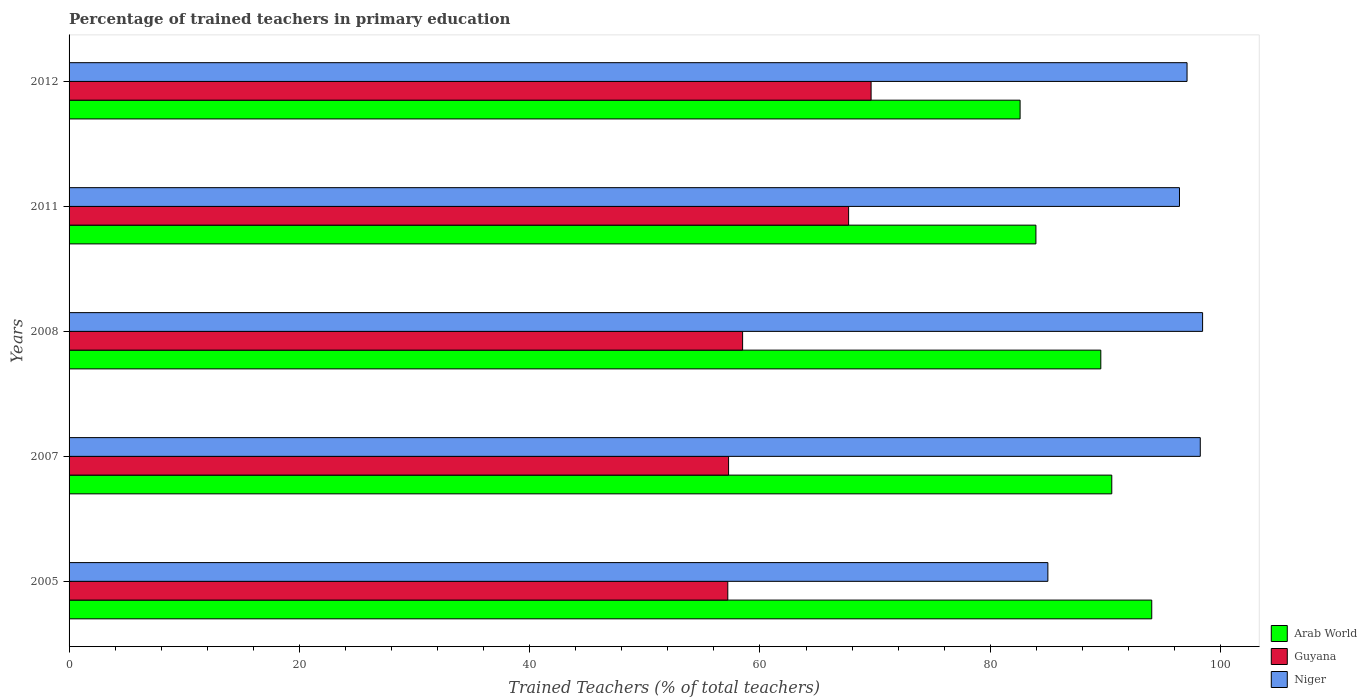How many groups of bars are there?
Keep it short and to the point. 5. How many bars are there on the 5th tick from the top?
Provide a succinct answer. 3. How many bars are there on the 4th tick from the bottom?
Offer a terse response. 3. What is the label of the 2nd group of bars from the top?
Provide a short and direct response. 2011. What is the percentage of trained teachers in Guyana in 2012?
Your answer should be compact. 69.65. Across all years, what is the maximum percentage of trained teachers in Arab World?
Provide a succinct answer. 94.02. Across all years, what is the minimum percentage of trained teachers in Guyana?
Ensure brevity in your answer.  57.2. In which year was the percentage of trained teachers in Guyana maximum?
Keep it short and to the point. 2012. What is the total percentage of trained teachers in Guyana in the graph?
Offer a terse response. 310.32. What is the difference between the percentage of trained teachers in Guyana in 2005 and that in 2011?
Offer a terse response. -10.49. What is the difference between the percentage of trained teachers in Arab World in 2005 and the percentage of trained teachers in Guyana in 2012?
Ensure brevity in your answer.  24.37. What is the average percentage of trained teachers in Arab World per year?
Ensure brevity in your answer.  88.14. In the year 2012, what is the difference between the percentage of trained teachers in Guyana and percentage of trained teachers in Arab World?
Provide a short and direct response. -12.94. What is the ratio of the percentage of trained teachers in Niger in 2007 to that in 2011?
Make the answer very short. 1.02. Is the difference between the percentage of trained teachers in Guyana in 2011 and 2012 greater than the difference between the percentage of trained teachers in Arab World in 2011 and 2012?
Ensure brevity in your answer.  No. What is the difference between the highest and the second highest percentage of trained teachers in Guyana?
Your response must be concise. 1.95. What is the difference between the highest and the lowest percentage of trained teachers in Niger?
Your response must be concise. 13.44. Is the sum of the percentage of trained teachers in Guyana in 2005 and 2011 greater than the maximum percentage of trained teachers in Arab World across all years?
Keep it short and to the point. Yes. What does the 1st bar from the top in 2011 represents?
Make the answer very short. Niger. What does the 2nd bar from the bottom in 2005 represents?
Ensure brevity in your answer.  Guyana. How many years are there in the graph?
Ensure brevity in your answer.  5. Are the values on the major ticks of X-axis written in scientific E-notation?
Offer a terse response. No. Does the graph contain any zero values?
Your answer should be compact. No. Does the graph contain grids?
Offer a very short reply. No. Where does the legend appear in the graph?
Offer a very short reply. Bottom right. How many legend labels are there?
Your answer should be compact. 3. How are the legend labels stacked?
Your answer should be very brief. Vertical. What is the title of the graph?
Offer a terse response. Percentage of trained teachers in primary education. What is the label or title of the X-axis?
Provide a succinct answer. Trained Teachers (% of total teachers). What is the Trained Teachers (% of total teachers) of Arab World in 2005?
Offer a very short reply. 94.02. What is the Trained Teachers (% of total teachers) of Guyana in 2005?
Make the answer very short. 57.2. What is the Trained Teachers (% of total teachers) of Niger in 2005?
Offer a terse response. 85. What is the Trained Teachers (% of total teachers) in Arab World in 2007?
Ensure brevity in your answer.  90.55. What is the Trained Teachers (% of total teachers) of Guyana in 2007?
Offer a terse response. 57.27. What is the Trained Teachers (% of total teachers) of Niger in 2007?
Your response must be concise. 98.24. What is the Trained Teachers (% of total teachers) of Arab World in 2008?
Your answer should be compact. 89.6. What is the Trained Teachers (% of total teachers) in Guyana in 2008?
Your answer should be compact. 58.49. What is the Trained Teachers (% of total teachers) of Niger in 2008?
Your answer should be very brief. 98.44. What is the Trained Teachers (% of total teachers) in Arab World in 2011?
Your answer should be compact. 83.96. What is the Trained Teachers (% of total teachers) of Guyana in 2011?
Make the answer very short. 67.7. What is the Trained Teachers (% of total teachers) in Niger in 2011?
Provide a short and direct response. 96.43. What is the Trained Teachers (% of total teachers) in Arab World in 2012?
Give a very brief answer. 82.59. What is the Trained Teachers (% of total teachers) in Guyana in 2012?
Make the answer very short. 69.65. What is the Trained Teachers (% of total teachers) in Niger in 2012?
Provide a succinct answer. 97.09. Across all years, what is the maximum Trained Teachers (% of total teachers) in Arab World?
Provide a succinct answer. 94.02. Across all years, what is the maximum Trained Teachers (% of total teachers) of Guyana?
Make the answer very short. 69.65. Across all years, what is the maximum Trained Teachers (% of total teachers) of Niger?
Make the answer very short. 98.44. Across all years, what is the minimum Trained Teachers (% of total teachers) of Arab World?
Your response must be concise. 82.59. Across all years, what is the minimum Trained Teachers (% of total teachers) of Guyana?
Offer a terse response. 57.2. Across all years, what is the minimum Trained Teachers (% of total teachers) in Niger?
Ensure brevity in your answer.  85. What is the total Trained Teachers (% of total teachers) of Arab World in the graph?
Keep it short and to the point. 440.72. What is the total Trained Teachers (% of total teachers) in Guyana in the graph?
Give a very brief answer. 310.32. What is the total Trained Teachers (% of total teachers) of Niger in the graph?
Keep it short and to the point. 475.19. What is the difference between the Trained Teachers (% of total teachers) of Arab World in 2005 and that in 2007?
Your response must be concise. 3.47. What is the difference between the Trained Teachers (% of total teachers) in Guyana in 2005 and that in 2007?
Ensure brevity in your answer.  -0.07. What is the difference between the Trained Teachers (% of total teachers) of Niger in 2005 and that in 2007?
Offer a very short reply. -13.24. What is the difference between the Trained Teachers (% of total teachers) in Arab World in 2005 and that in 2008?
Your response must be concise. 4.42. What is the difference between the Trained Teachers (% of total teachers) of Guyana in 2005 and that in 2008?
Your answer should be compact. -1.29. What is the difference between the Trained Teachers (% of total teachers) in Niger in 2005 and that in 2008?
Your answer should be compact. -13.44. What is the difference between the Trained Teachers (% of total teachers) in Arab World in 2005 and that in 2011?
Keep it short and to the point. 10.06. What is the difference between the Trained Teachers (% of total teachers) in Guyana in 2005 and that in 2011?
Provide a short and direct response. -10.49. What is the difference between the Trained Teachers (% of total teachers) of Niger in 2005 and that in 2011?
Your answer should be compact. -11.43. What is the difference between the Trained Teachers (% of total teachers) of Arab World in 2005 and that in 2012?
Provide a succinct answer. 11.43. What is the difference between the Trained Teachers (% of total teachers) of Guyana in 2005 and that in 2012?
Offer a very short reply. -12.44. What is the difference between the Trained Teachers (% of total teachers) in Niger in 2005 and that in 2012?
Your response must be concise. -12.09. What is the difference between the Trained Teachers (% of total teachers) of Guyana in 2007 and that in 2008?
Your answer should be compact. -1.22. What is the difference between the Trained Teachers (% of total teachers) in Niger in 2007 and that in 2008?
Provide a short and direct response. -0.2. What is the difference between the Trained Teachers (% of total teachers) of Arab World in 2007 and that in 2011?
Provide a succinct answer. 6.59. What is the difference between the Trained Teachers (% of total teachers) in Guyana in 2007 and that in 2011?
Your response must be concise. -10.42. What is the difference between the Trained Teachers (% of total teachers) of Niger in 2007 and that in 2011?
Keep it short and to the point. 1.81. What is the difference between the Trained Teachers (% of total teachers) of Arab World in 2007 and that in 2012?
Provide a succinct answer. 7.96. What is the difference between the Trained Teachers (% of total teachers) of Guyana in 2007 and that in 2012?
Ensure brevity in your answer.  -12.38. What is the difference between the Trained Teachers (% of total teachers) of Niger in 2007 and that in 2012?
Your answer should be very brief. 1.15. What is the difference between the Trained Teachers (% of total teachers) of Arab World in 2008 and that in 2011?
Your answer should be compact. 5.64. What is the difference between the Trained Teachers (% of total teachers) in Guyana in 2008 and that in 2011?
Provide a short and direct response. -9.21. What is the difference between the Trained Teachers (% of total teachers) of Niger in 2008 and that in 2011?
Make the answer very short. 2.01. What is the difference between the Trained Teachers (% of total teachers) of Arab World in 2008 and that in 2012?
Offer a very short reply. 7.01. What is the difference between the Trained Teachers (% of total teachers) in Guyana in 2008 and that in 2012?
Keep it short and to the point. -11.16. What is the difference between the Trained Teachers (% of total teachers) of Niger in 2008 and that in 2012?
Keep it short and to the point. 1.35. What is the difference between the Trained Teachers (% of total teachers) in Arab World in 2011 and that in 2012?
Keep it short and to the point. 1.37. What is the difference between the Trained Teachers (% of total teachers) in Guyana in 2011 and that in 2012?
Make the answer very short. -1.95. What is the difference between the Trained Teachers (% of total teachers) of Niger in 2011 and that in 2012?
Give a very brief answer. -0.66. What is the difference between the Trained Teachers (% of total teachers) of Arab World in 2005 and the Trained Teachers (% of total teachers) of Guyana in 2007?
Your answer should be very brief. 36.75. What is the difference between the Trained Teachers (% of total teachers) in Arab World in 2005 and the Trained Teachers (% of total teachers) in Niger in 2007?
Offer a very short reply. -4.21. What is the difference between the Trained Teachers (% of total teachers) of Guyana in 2005 and the Trained Teachers (% of total teachers) of Niger in 2007?
Provide a succinct answer. -41.03. What is the difference between the Trained Teachers (% of total teachers) of Arab World in 2005 and the Trained Teachers (% of total teachers) of Guyana in 2008?
Your answer should be compact. 35.53. What is the difference between the Trained Teachers (% of total teachers) in Arab World in 2005 and the Trained Teachers (% of total teachers) in Niger in 2008?
Your answer should be compact. -4.42. What is the difference between the Trained Teachers (% of total teachers) of Guyana in 2005 and the Trained Teachers (% of total teachers) of Niger in 2008?
Your response must be concise. -41.23. What is the difference between the Trained Teachers (% of total teachers) in Arab World in 2005 and the Trained Teachers (% of total teachers) in Guyana in 2011?
Offer a very short reply. 26.33. What is the difference between the Trained Teachers (% of total teachers) in Arab World in 2005 and the Trained Teachers (% of total teachers) in Niger in 2011?
Keep it short and to the point. -2.41. What is the difference between the Trained Teachers (% of total teachers) of Guyana in 2005 and the Trained Teachers (% of total teachers) of Niger in 2011?
Offer a very short reply. -39.23. What is the difference between the Trained Teachers (% of total teachers) of Arab World in 2005 and the Trained Teachers (% of total teachers) of Guyana in 2012?
Keep it short and to the point. 24.37. What is the difference between the Trained Teachers (% of total teachers) of Arab World in 2005 and the Trained Teachers (% of total teachers) of Niger in 2012?
Your answer should be compact. -3.07. What is the difference between the Trained Teachers (% of total teachers) of Guyana in 2005 and the Trained Teachers (% of total teachers) of Niger in 2012?
Ensure brevity in your answer.  -39.88. What is the difference between the Trained Teachers (% of total teachers) of Arab World in 2007 and the Trained Teachers (% of total teachers) of Guyana in 2008?
Offer a very short reply. 32.06. What is the difference between the Trained Teachers (% of total teachers) in Arab World in 2007 and the Trained Teachers (% of total teachers) in Niger in 2008?
Provide a succinct answer. -7.89. What is the difference between the Trained Teachers (% of total teachers) of Guyana in 2007 and the Trained Teachers (% of total teachers) of Niger in 2008?
Your answer should be compact. -41.16. What is the difference between the Trained Teachers (% of total teachers) in Arab World in 2007 and the Trained Teachers (% of total teachers) in Guyana in 2011?
Your response must be concise. 22.85. What is the difference between the Trained Teachers (% of total teachers) of Arab World in 2007 and the Trained Teachers (% of total teachers) of Niger in 2011?
Offer a terse response. -5.88. What is the difference between the Trained Teachers (% of total teachers) in Guyana in 2007 and the Trained Teachers (% of total teachers) in Niger in 2011?
Offer a very short reply. -39.16. What is the difference between the Trained Teachers (% of total teachers) in Arab World in 2007 and the Trained Teachers (% of total teachers) in Guyana in 2012?
Provide a short and direct response. 20.9. What is the difference between the Trained Teachers (% of total teachers) of Arab World in 2007 and the Trained Teachers (% of total teachers) of Niger in 2012?
Give a very brief answer. -6.54. What is the difference between the Trained Teachers (% of total teachers) of Guyana in 2007 and the Trained Teachers (% of total teachers) of Niger in 2012?
Provide a succinct answer. -39.81. What is the difference between the Trained Teachers (% of total teachers) of Arab World in 2008 and the Trained Teachers (% of total teachers) of Guyana in 2011?
Offer a very short reply. 21.9. What is the difference between the Trained Teachers (% of total teachers) in Arab World in 2008 and the Trained Teachers (% of total teachers) in Niger in 2011?
Ensure brevity in your answer.  -6.83. What is the difference between the Trained Teachers (% of total teachers) of Guyana in 2008 and the Trained Teachers (% of total teachers) of Niger in 2011?
Offer a terse response. -37.94. What is the difference between the Trained Teachers (% of total teachers) of Arab World in 2008 and the Trained Teachers (% of total teachers) of Guyana in 2012?
Your answer should be very brief. 19.95. What is the difference between the Trained Teachers (% of total teachers) in Arab World in 2008 and the Trained Teachers (% of total teachers) in Niger in 2012?
Offer a very short reply. -7.49. What is the difference between the Trained Teachers (% of total teachers) in Guyana in 2008 and the Trained Teachers (% of total teachers) in Niger in 2012?
Provide a short and direct response. -38.6. What is the difference between the Trained Teachers (% of total teachers) of Arab World in 2011 and the Trained Teachers (% of total teachers) of Guyana in 2012?
Your response must be concise. 14.31. What is the difference between the Trained Teachers (% of total teachers) of Arab World in 2011 and the Trained Teachers (% of total teachers) of Niger in 2012?
Provide a succinct answer. -13.12. What is the difference between the Trained Teachers (% of total teachers) in Guyana in 2011 and the Trained Teachers (% of total teachers) in Niger in 2012?
Make the answer very short. -29.39. What is the average Trained Teachers (% of total teachers) of Arab World per year?
Your answer should be very brief. 88.14. What is the average Trained Teachers (% of total teachers) in Guyana per year?
Offer a terse response. 62.06. What is the average Trained Teachers (% of total teachers) in Niger per year?
Ensure brevity in your answer.  95.04. In the year 2005, what is the difference between the Trained Teachers (% of total teachers) in Arab World and Trained Teachers (% of total teachers) in Guyana?
Give a very brief answer. 36.82. In the year 2005, what is the difference between the Trained Teachers (% of total teachers) in Arab World and Trained Teachers (% of total teachers) in Niger?
Make the answer very short. 9.02. In the year 2005, what is the difference between the Trained Teachers (% of total teachers) in Guyana and Trained Teachers (% of total teachers) in Niger?
Ensure brevity in your answer.  -27.8. In the year 2007, what is the difference between the Trained Teachers (% of total teachers) in Arab World and Trained Teachers (% of total teachers) in Guyana?
Give a very brief answer. 33.28. In the year 2007, what is the difference between the Trained Teachers (% of total teachers) in Arab World and Trained Teachers (% of total teachers) in Niger?
Keep it short and to the point. -7.69. In the year 2007, what is the difference between the Trained Teachers (% of total teachers) of Guyana and Trained Teachers (% of total teachers) of Niger?
Provide a succinct answer. -40.96. In the year 2008, what is the difference between the Trained Teachers (% of total teachers) in Arab World and Trained Teachers (% of total teachers) in Guyana?
Your answer should be very brief. 31.11. In the year 2008, what is the difference between the Trained Teachers (% of total teachers) of Arab World and Trained Teachers (% of total teachers) of Niger?
Your answer should be compact. -8.84. In the year 2008, what is the difference between the Trained Teachers (% of total teachers) in Guyana and Trained Teachers (% of total teachers) in Niger?
Give a very brief answer. -39.95. In the year 2011, what is the difference between the Trained Teachers (% of total teachers) in Arab World and Trained Teachers (% of total teachers) in Guyana?
Your answer should be compact. 16.27. In the year 2011, what is the difference between the Trained Teachers (% of total teachers) of Arab World and Trained Teachers (% of total teachers) of Niger?
Your answer should be compact. -12.47. In the year 2011, what is the difference between the Trained Teachers (% of total teachers) of Guyana and Trained Teachers (% of total teachers) of Niger?
Offer a very short reply. -28.73. In the year 2012, what is the difference between the Trained Teachers (% of total teachers) of Arab World and Trained Teachers (% of total teachers) of Guyana?
Provide a succinct answer. 12.94. In the year 2012, what is the difference between the Trained Teachers (% of total teachers) of Arab World and Trained Teachers (% of total teachers) of Niger?
Offer a very short reply. -14.5. In the year 2012, what is the difference between the Trained Teachers (% of total teachers) of Guyana and Trained Teachers (% of total teachers) of Niger?
Your response must be concise. -27.44. What is the ratio of the Trained Teachers (% of total teachers) in Arab World in 2005 to that in 2007?
Offer a terse response. 1.04. What is the ratio of the Trained Teachers (% of total teachers) of Niger in 2005 to that in 2007?
Your response must be concise. 0.87. What is the ratio of the Trained Teachers (% of total teachers) of Arab World in 2005 to that in 2008?
Make the answer very short. 1.05. What is the ratio of the Trained Teachers (% of total teachers) in Niger in 2005 to that in 2008?
Provide a succinct answer. 0.86. What is the ratio of the Trained Teachers (% of total teachers) in Arab World in 2005 to that in 2011?
Provide a succinct answer. 1.12. What is the ratio of the Trained Teachers (% of total teachers) of Guyana in 2005 to that in 2011?
Make the answer very short. 0.84. What is the ratio of the Trained Teachers (% of total teachers) in Niger in 2005 to that in 2011?
Your response must be concise. 0.88. What is the ratio of the Trained Teachers (% of total teachers) in Arab World in 2005 to that in 2012?
Offer a terse response. 1.14. What is the ratio of the Trained Teachers (% of total teachers) of Guyana in 2005 to that in 2012?
Give a very brief answer. 0.82. What is the ratio of the Trained Teachers (% of total teachers) in Niger in 2005 to that in 2012?
Keep it short and to the point. 0.88. What is the ratio of the Trained Teachers (% of total teachers) of Arab World in 2007 to that in 2008?
Keep it short and to the point. 1.01. What is the ratio of the Trained Teachers (% of total teachers) in Guyana in 2007 to that in 2008?
Keep it short and to the point. 0.98. What is the ratio of the Trained Teachers (% of total teachers) in Niger in 2007 to that in 2008?
Your answer should be very brief. 1. What is the ratio of the Trained Teachers (% of total teachers) in Arab World in 2007 to that in 2011?
Provide a succinct answer. 1.08. What is the ratio of the Trained Teachers (% of total teachers) of Guyana in 2007 to that in 2011?
Provide a succinct answer. 0.85. What is the ratio of the Trained Teachers (% of total teachers) of Niger in 2007 to that in 2011?
Your answer should be very brief. 1.02. What is the ratio of the Trained Teachers (% of total teachers) of Arab World in 2007 to that in 2012?
Your answer should be compact. 1.1. What is the ratio of the Trained Teachers (% of total teachers) in Guyana in 2007 to that in 2012?
Your answer should be compact. 0.82. What is the ratio of the Trained Teachers (% of total teachers) of Niger in 2007 to that in 2012?
Make the answer very short. 1.01. What is the ratio of the Trained Teachers (% of total teachers) of Arab World in 2008 to that in 2011?
Ensure brevity in your answer.  1.07. What is the ratio of the Trained Teachers (% of total teachers) in Guyana in 2008 to that in 2011?
Offer a very short reply. 0.86. What is the ratio of the Trained Teachers (% of total teachers) of Niger in 2008 to that in 2011?
Make the answer very short. 1.02. What is the ratio of the Trained Teachers (% of total teachers) in Arab World in 2008 to that in 2012?
Make the answer very short. 1.08. What is the ratio of the Trained Teachers (% of total teachers) of Guyana in 2008 to that in 2012?
Give a very brief answer. 0.84. What is the ratio of the Trained Teachers (% of total teachers) in Niger in 2008 to that in 2012?
Keep it short and to the point. 1.01. What is the ratio of the Trained Teachers (% of total teachers) in Arab World in 2011 to that in 2012?
Offer a very short reply. 1.02. What is the ratio of the Trained Teachers (% of total teachers) of Guyana in 2011 to that in 2012?
Keep it short and to the point. 0.97. What is the ratio of the Trained Teachers (% of total teachers) in Niger in 2011 to that in 2012?
Offer a terse response. 0.99. What is the difference between the highest and the second highest Trained Teachers (% of total teachers) of Arab World?
Ensure brevity in your answer.  3.47. What is the difference between the highest and the second highest Trained Teachers (% of total teachers) in Guyana?
Provide a short and direct response. 1.95. What is the difference between the highest and the second highest Trained Teachers (% of total teachers) of Niger?
Make the answer very short. 0.2. What is the difference between the highest and the lowest Trained Teachers (% of total teachers) of Arab World?
Offer a very short reply. 11.43. What is the difference between the highest and the lowest Trained Teachers (% of total teachers) of Guyana?
Ensure brevity in your answer.  12.44. What is the difference between the highest and the lowest Trained Teachers (% of total teachers) in Niger?
Give a very brief answer. 13.44. 